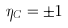Convert formula to latex. <formula><loc_0><loc_0><loc_500><loc_500>\eta _ { C } = \pm 1</formula> 